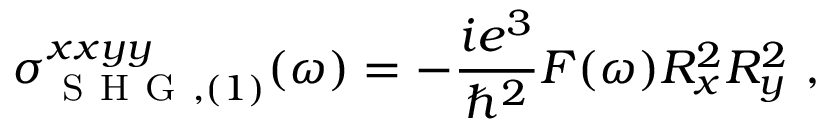<formula> <loc_0><loc_0><loc_500><loc_500>\sigma _ { S H G , ( 1 ) } ^ { x x y y } ( \omega ) = - \frac { i e ^ { 3 } } { \hslash ^ { 2 } } F ( \omega ) R _ { x } ^ { 2 } R _ { y } ^ { 2 } ,</formula> 